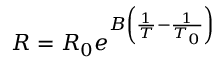Convert formula to latex. <formula><loc_0><loc_0><loc_500><loc_500>R = R _ { 0 } e ^ { B \left ( { \frac { 1 } { T } } - { \frac { 1 } { T _ { 0 } } } \right ) }</formula> 